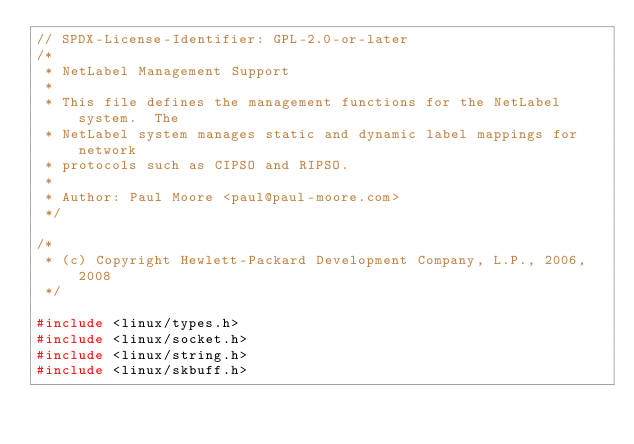<code> <loc_0><loc_0><loc_500><loc_500><_C_>// SPDX-License-Identifier: GPL-2.0-or-later
/*
 * NetLabel Management Support
 *
 * This file defines the management functions for the NetLabel system.  The
 * NetLabel system manages static and dynamic label mappings for network
 * protocols such as CIPSO and RIPSO.
 *
 * Author: Paul Moore <paul@paul-moore.com>
 */

/*
 * (c) Copyright Hewlett-Packard Development Company, L.P., 2006, 2008
 */

#include <linux/types.h>
#include <linux/socket.h>
#include <linux/string.h>
#include <linux/skbuff.h></code> 